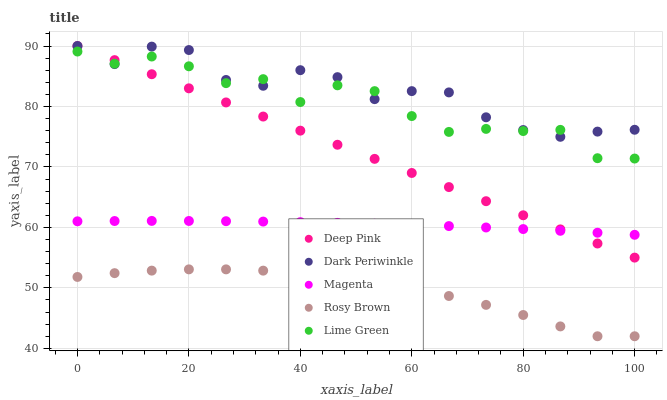Does Rosy Brown have the minimum area under the curve?
Answer yes or no. Yes. Does Dark Periwinkle have the maximum area under the curve?
Answer yes or no. Yes. Does Deep Pink have the minimum area under the curve?
Answer yes or no. No. Does Deep Pink have the maximum area under the curve?
Answer yes or no. No. Is Deep Pink the smoothest?
Answer yes or no. Yes. Is Lime Green the roughest?
Answer yes or no. Yes. Is Lime Green the smoothest?
Answer yes or no. No. Is Deep Pink the roughest?
Answer yes or no. No. Does Rosy Brown have the lowest value?
Answer yes or no. Yes. Does Deep Pink have the lowest value?
Answer yes or no. No. Does Dark Periwinkle have the highest value?
Answer yes or no. Yes. Does Lime Green have the highest value?
Answer yes or no. No. Is Rosy Brown less than Lime Green?
Answer yes or no. Yes. Is Dark Periwinkle greater than Magenta?
Answer yes or no. Yes. Does Deep Pink intersect Lime Green?
Answer yes or no. Yes. Is Deep Pink less than Lime Green?
Answer yes or no. No. Is Deep Pink greater than Lime Green?
Answer yes or no. No. Does Rosy Brown intersect Lime Green?
Answer yes or no. No. 